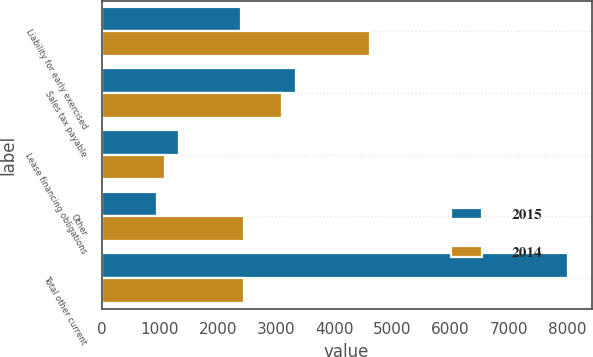<chart> <loc_0><loc_0><loc_500><loc_500><stacked_bar_chart><ecel><fcel>Liability for early exercised<fcel>Sales tax payable<fcel>Lease financing obligations<fcel>Other<fcel>Total other current<nl><fcel>2015<fcel>2390<fcel>3347<fcel>1336<fcel>952<fcel>8025<nl><fcel>2014<fcel>4616<fcel>3101<fcel>1087<fcel>2445<fcel>2445<nl></chart> 